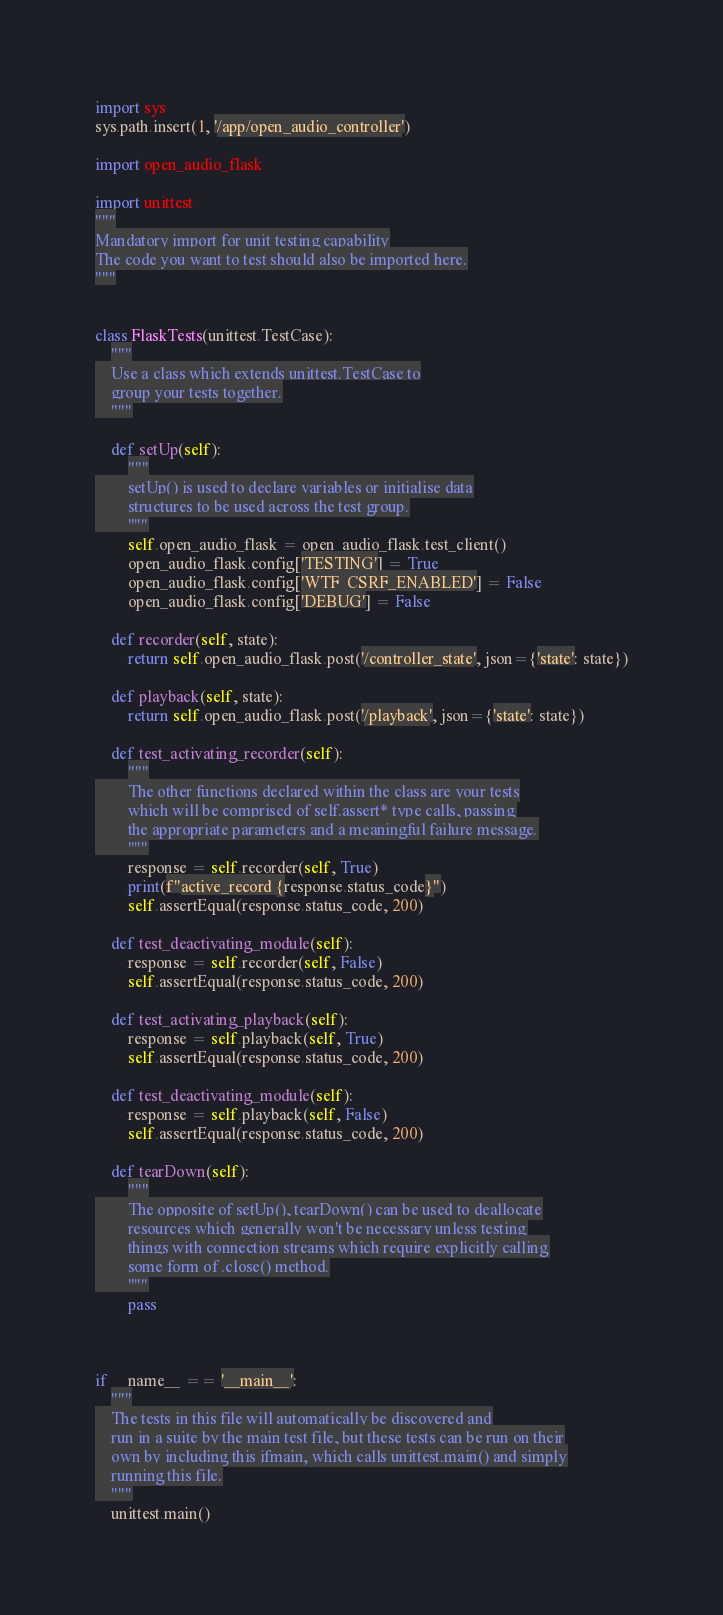<code> <loc_0><loc_0><loc_500><loc_500><_Python_>import sys
sys.path.insert(1, '/app/open_audio_controller')

import open_audio_flask

import unittest
"""
Mandatory import for unit testing capability
The code you want to test should also be imported here.
"""


class FlaskTests(unittest.TestCase):
    """
    Use a class which extends unittest.TestCase to
    group your tests together.
    """

    def setUp(self):
        """
        setUp() is used to declare variables or initialise data
        structures to be used across the test group.
        """
        self.open_audio_flask = open_audio_flask.test_client()
        open_audio_flask.config['TESTING'] = True
        open_audio_flask.config['WTF_CSRF_ENABLED'] = False
        open_audio_flask.config['DEBUG'] = False

    def recorder(self, state):
        return self.open_audio_flask.post('/controller_state', json={'state': state})

    def playback(self, state):
        return self.open_audio_flask.post('/playback', json={'state': state})

    def test_activating_recorder(self):
        """
        The other functions declared within the class are your tests
        which will be comprised of self.assert* type calls, passing
        the appropriate parameters and a meaningful failure message.
        """
        response = self.recorder(self, True)
        print(f"active_record {response.status_code}")
        self.assertEqual(response.status_code, 200)

    def test_deactivating_module(self):
        response = self.recorder(self, False)
        self.assertEqual(response.status_code, 200)

    def test_activating_playback(self):
        response = self.playback(self, True)
        self.assertEqual(response.status_code, 200)

    def test_deactivating_module(self):
        response = self.playback(self, False)
        self.assertEqual(response.status_code, 200)

    def tearDown(self):
        """
        The opposite of setUp(), tearDown() can be used to deallocate
        resources which generally won't be necessary unless testing
        things with connection streams which require explicitly calling
        some form of .close() method.
        """
        pass



if __name__ == '__main__':
    """
    The tests in this file will automatically be discovered and
    run in a suite by the main test file, but these tests can be run on their
    own by including this ifmain, which calls unittest.main() and simply
    running this file.
    """
    unittest.main()
</code> 